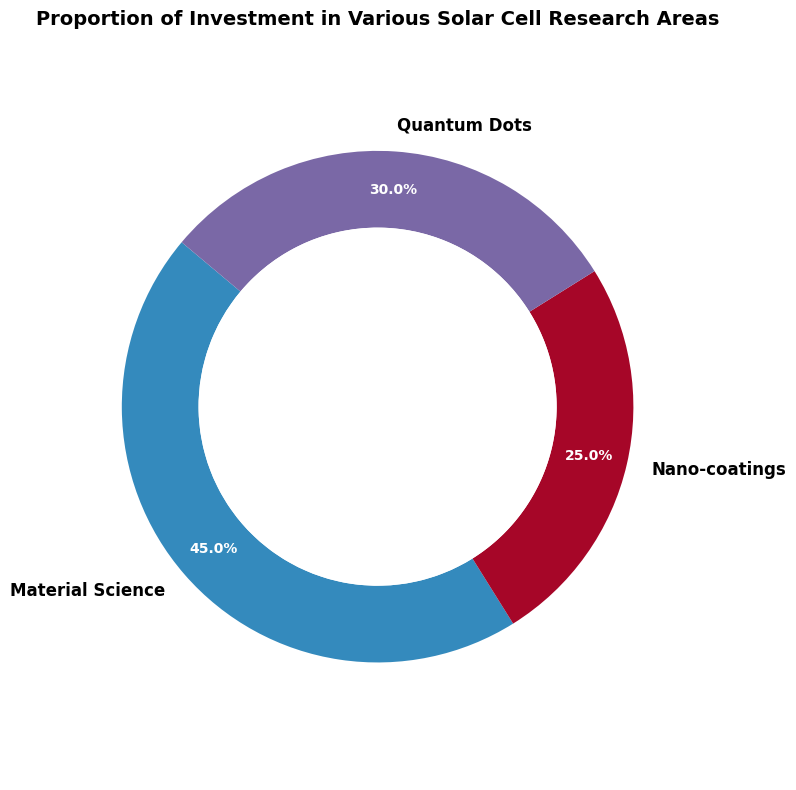What is the largest proportion of investment in a single category? From the ring chart, the sector with the largest proportion of investment is Material Science, which occupies 45% of the total.
Answer: 45% Which category receives the smallest proportion of investment? Observing the ring chart, Nano-coatings have the smallest investment proportion at 25%.
Answer: Nano-coatings How much more is invested in Material Science compared to Quantum Dots? Material Science has 45%, and Quantum Dots have 30%. The difference is 45% - 30% = 15%.
Answer: 15% What is the total proportion of investment for Nano-coatings and Quantum Dots combined? The investment proportions are 25% for Nano-coatings and 30% for Quantum Dots. Summing these gives 25% + 30% = 55%.
Answer: 55% If an additional 10% investment were added equally to Nano-coatings and Quantum Dots, what would their new proportions be? Currently, Nano-coatings have 25% and Quantum Dots have 30%. Adding 5% to each would result in 25% + 5% = 30% for Nano-coatings and 30% + 5% = 35% for Quantum Dots.
Answer: Nano-coatings: 30%, Quantum Dots: 35% Which segment appears larger visually, Nano-coatings or Quantum Dots, and why do you think that is? Quantum Dots visually appears larger than Nano-coatings because its segment is labeled as 30%, which is greater than the 25% for Nano-coatings.
Answer: Quantum Dots How much smaller is the proportion of investment in Nano-coatings compared to Material Science and Quantum Dots combined? Material Science + Quantum Dots = 45% + 30% = 75%. Nano-coatings = 25%. The difference is 75% - 25% = 50%.
Answer: 50% Is the investment in Material Science more than the combined investment in Nano-coatings and Quantum Dots? Material Science has 45% investment. Nano-coatings and Quantum Dots together have 25% + 30% = 55%. Since 45% < 55%, the investment in Material Science is not more.
Answer: No What is the average proportion of investment across all categories? The proportions are 45% for Material Science, 25% for Nano-coatings, and 30% for Quantum Dots. The average is (45% + 25% + 30%) / 3 = 100% / 3 = 33.33%.
Answer: 33.33% By how much does the proportion of investment in Material Science exceed the proportion of investment in Nano-coatings? The investment in Material Science is 45%, while in Nano-coatings it is 25%. The difference is 45% - 25% = 20%.
Answer: 20% 